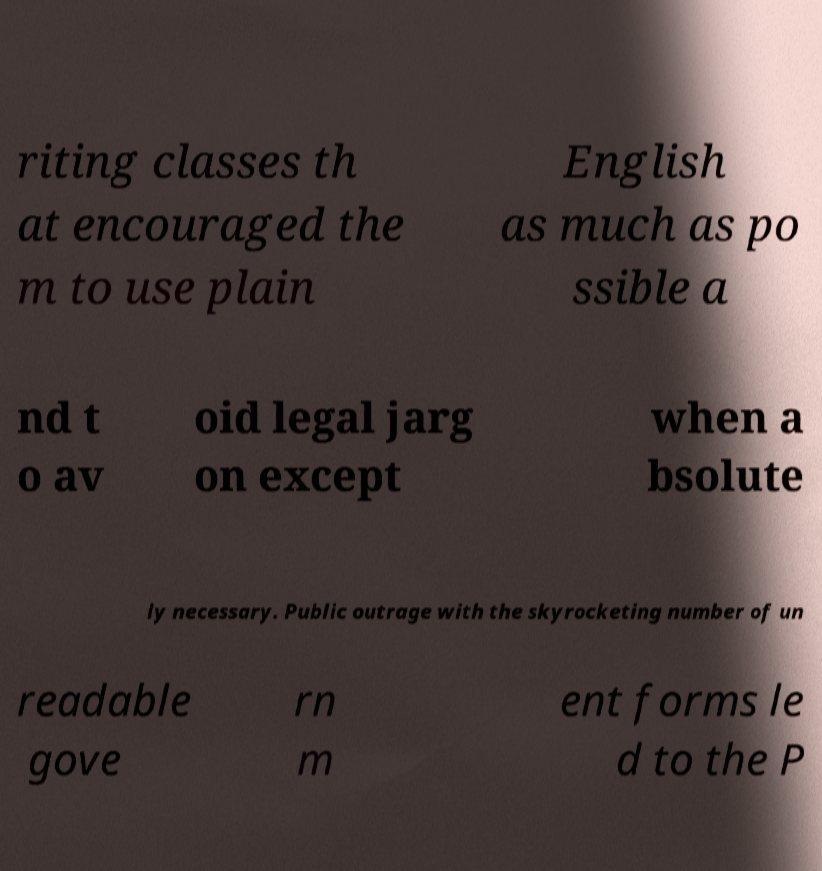Please read and relay the text visible in this image. What does it say? riting classes th at encouraged the m to use plain English as much as po ssible a nd t o av oid legal jarg on except when a bsolute ly necessary. Public outrage with the skyrocketing number of un readable gove rn m ent forms le d to the P 